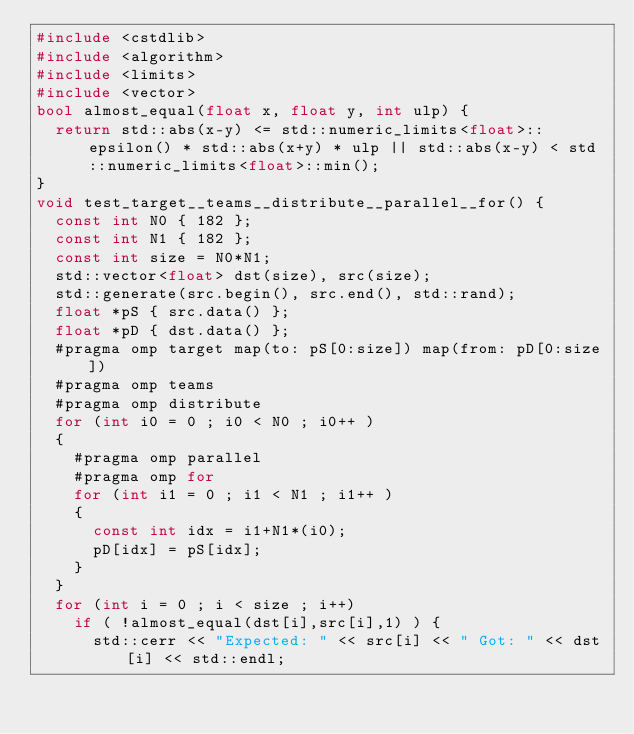<code> <loc_0><loc_0><loc_500><loc_500><_C++_>#include <cstdlib>
#include <algorithm>
#include <limits>
#include <vector>
bool almost_equal(float x, float y, int ulp) {
  return std::abs(x-y) <= std::numeric_limits<float>::epsilon() * std::abs(x+y) * ulp || std::abs(x-y) < std::numeric_limits<float>::min();
}
void test_target__teams__distribute__parallel__for() {
  const int N0 { 182 };
  const int N1 { 182 };
  const int size = N0*N1;
  std::vector<float> dst(size), src(size);
  std::generate(src.begin(), src.end(), std::rand);
  float *pS { src.data() };
  float *pD { dst.data() };
  #pragma omp target map(to: pS[0:size]) map(from: pD[0:size])
  #pragma omp teams
  #pragma omp distribute
  for (int i0 = 0 ; i0 < N0 ; i0++ )
  {
    #pragma omp parallel
    #pragma omp for
    for (int i1 = 0 ; i1 < N1 ; i1++ )
    {
      const int idx = i1+N1*(i0);
      pD[idx] = pS[idx];
    }
  }
  for (int i = 0 ; i < size ; i++)
    if ( !almost_equal(dst[i],src[i],1) ) {
      std::cerr << "Expected: " << src[i] << " Got: " << dst[i] << std::endl;</code> 